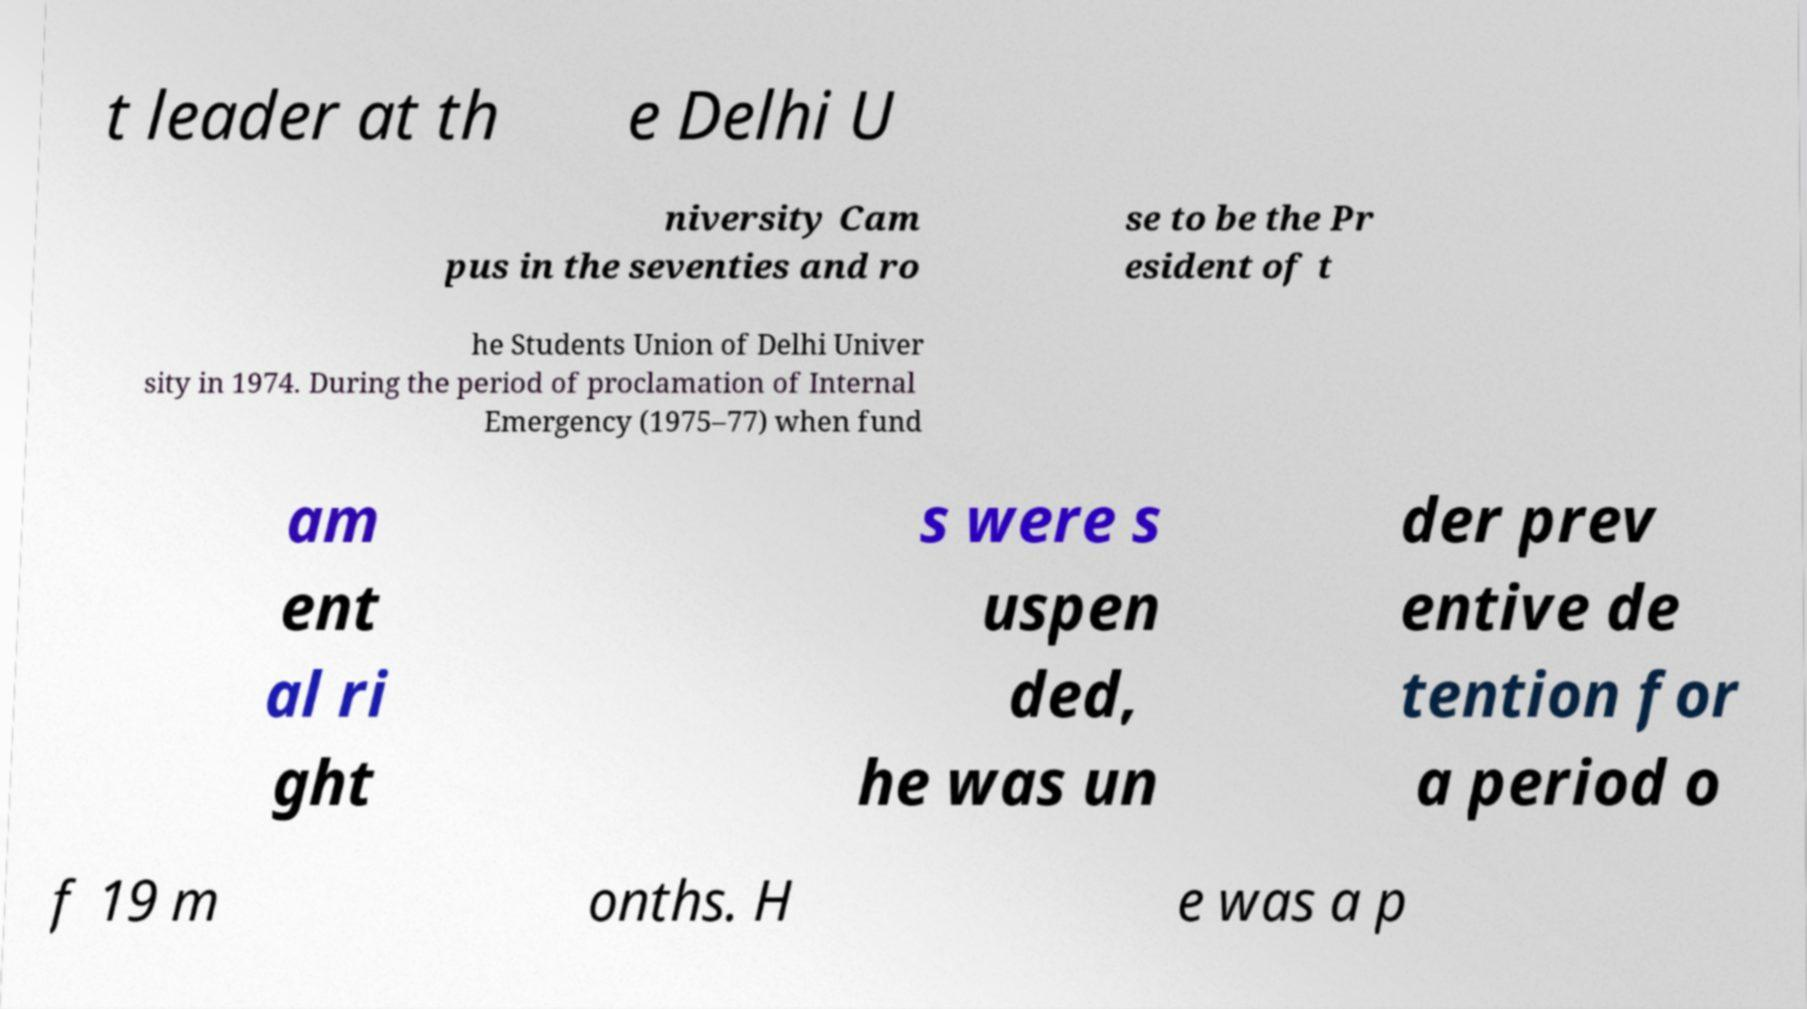Can you accurately transcribe the text from the provided image for me? t leader at th e Delhi U niversity Cam pus in the seventies and ro se to be the Pr esident of t he Students Union of Delhi Univer sity in 1974. During the period of proclamation of Internal Emergency (1975–77) when fund am ent al ri ght s were s uspen ded, he was un der prev entive de tention for a period o f 19 m onths. H e was a p 